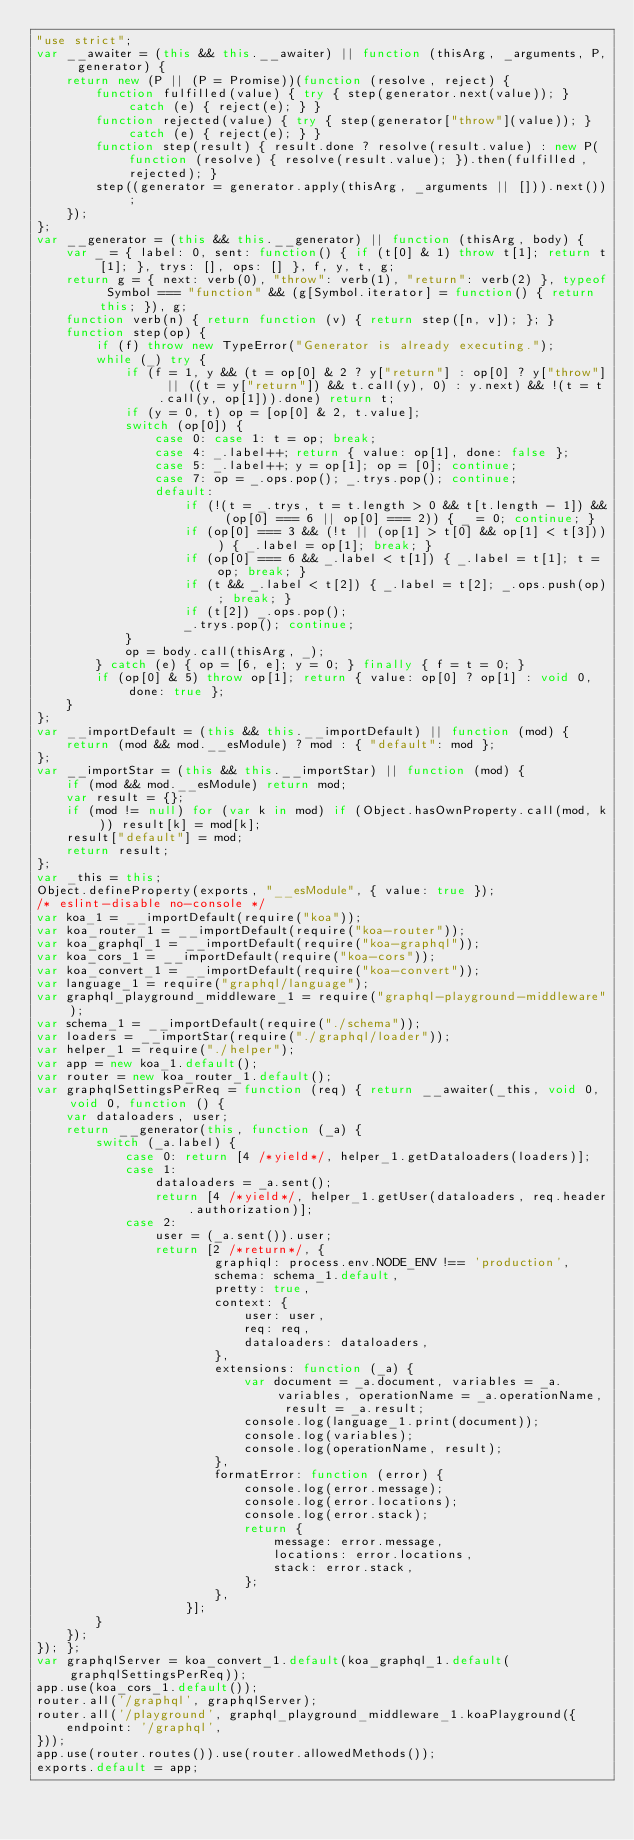<code> <loc_0><loc_0><loc_500><loc_500><_JavaScript_>"use strict";
var __awaiter = (this && this.__awaiter) || function (thisArg, _arguments, P, generator) {
    return new (P || (P = Promise))(function (resolve, reject) {
        function fulfilled(value) { try { step(generator.next(value)); } catch (e) { reject(e); } }
        function rejected(value) { try { step(generator["throw"](value)); } catch (e) { reject(e); } }
        function step(result) { result.done ? resolve(result.value) : new P(function (resolve) { resolve(result.value); }).then(fulfilled, rejected); }
        step((generator = generator.apply(thisArg, _arguments || [])).next());
    });
};
var __generator = (this && this.__generator) || function (thisArg, body) {
    var _ = { label: 0, sent: function() { if (t[0] & 1) throw t[1]; return t[1]; }, trys: [], ops: [] }, f, y, t, g;
    return g = { next: verb(0), "throw": verb(1), "return": verb(2) }, typeof Symbol === "function" && (g[Symbol.iterator] = function() { return this; }), g;
    function verb(n) { return function (v) { return step([n, v]); }; }
    function step(op) {
        if (f) throw new TypeError("Generator is already executing.");
        while (_) try {
            if (f = 1, y && (t = op[0] & 2 ? y["return"] : op[0] ? y["throw"] || ((t = y["return"]) && t.call(y), 0) : y.next) && !(t = t.call(y, op[1])).done) return t;
            if (y = 0, t) op = [op[0] & 2, t.value];
            switch (op[0]) {
                case 0: case 1: t = op; break;
                case 4: _.label++; return { value: op[1], done: false };
                case 5: _.label++; y = op[1]; op = [0]; continue;
                case 7: op = _.ops.pop(); _.trys.pop(); continue;
                default:
                    if (!(t = _.trys, t = t.length > 0 && t[t.length - 1]) && (op[0] === 6 || op[0] === 2)) { _ = 0; continue; }
                    if (op[0] === 3 && (!t || (op[1] > t[0] && op[1] < t[3]))) { _.label = op[1]; break; }
                    if (op[0] === 6 && _.label < t[1]) { _.label = t[1]; t = op; break; }
                    if (t && _.label < t[2]) { _.label = t[2]; _.ops.push(op); break; }
                    if (t[2]) _.ops.pop();
                    _.trys.pop(); continue;
            }
            op = body.call(thisArg, _);
        } catch (e) { op = [6, e]; y = 0; } finally { f = t = 0; }
        if (op[0] & 5) throw op[1]; return { value: op[0] ? op[1] : void 0, done: true };
    }
};
var __importDefault = (this && this.__importDefault) || function (mod) {
    return (mod && mod.__esModule) ? mod : { "default": mod };
};
var __importStar = (this && this.__importStar) || function (mod) {
    if (mod && mod.__esModule) return mod;
    var result = {};
    if (mod != null) for (var k in mod) if (Object.hasOwnProperty.call(mod, k)) result[k] = mod[k];
    result["default"] = mod;
    return result;
};
var _this = this;
Object.defineProperty(exports, "__esModule", { value: true });
/* eslint-disable no-console */
var koa_1 = __importDefault(require("koa"));
var koa_router_1 = __importDefault(require("koa-router"));
var koa_graphql_1 = __importDefault(require("koa-graphql"));
var koa_cors_1 = __importDefault(require("koa-cors"));
var koa_convert_1 = __importDefault(require("koa-convert"));
var language_1 = require("graphql/language");
var graphql_playground_middleware_1 = require("graphql-playground-middleware");
var schema_1 = __importDefault(require("./schema"));
var loaders = __importStar(require("./graphql/loader"));
var helper_1 = require("./helper");
var app = new koa_1.default();
var router = new koa_router_1.default();
var graphqlSettingsPerReq = function (req) { return __awaiter(_this, void 0, void 0, function () {
    var dataloaders, user;
    return __generator(this, function (_a) {
        switch (_a.label) {
            case 0: return [4 /*yield*/, helper_1.getDataloaders(loaders)];
            case 1:
                dataloaders = _a.sent();
                return [4 /*yield*/, helper_1.getUser(dataloaders, req.header.authorization)];
            case 2:
                user = (_a.sent()).user;
                return [2 /*return*/, {
                        graphiql: process.env.NODE_ENV !== 'production',
                        schema: schema_1.default,
                        pretty: true,
                        context: {
                            user: user,
                            req: req,
                            dataloaders: dataloaders,
                        },
                        extensions: function (_a) {
                            var document = _a.document, variables = _a.variables, operationName = _a.operationName, result = _a.result;
                            console.log(language_1.print(document));
                            console.log(variables);
                            console.log(operationName, result);
                        },
                        formatError: function (error) {
                            console.log(error.message);
                            console.log(error.locations);
                            console.log(error.stack);
                            return {
                                message: error.message,
                                locations: error.locations,
                                stack: error.stack,
                            };
                        },
                    }];
        }
    });
}); };
var graphqlServer = koa_convert_1.default(koa_graphql_1.default(graphqlSettingsPerReq));
app.use(koa_cors_1.default());
router.all('/graphql', graphqlServer);
router.all('/playground', graphql_playground_middleware_1.koaPlayground({
    endpoint: '/graphql',
}));
app.use(router.routes()).use(router.allowedMethods());
exports.default = app;
</code> 